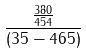Convert formula to latex. <formula><loc_0><loc_0><loc_500><loc_500>\frac { \frac { 3 8 0 } { 4 5 4 } } { ( 3 5 - 4 6 5 ) }</formula> 